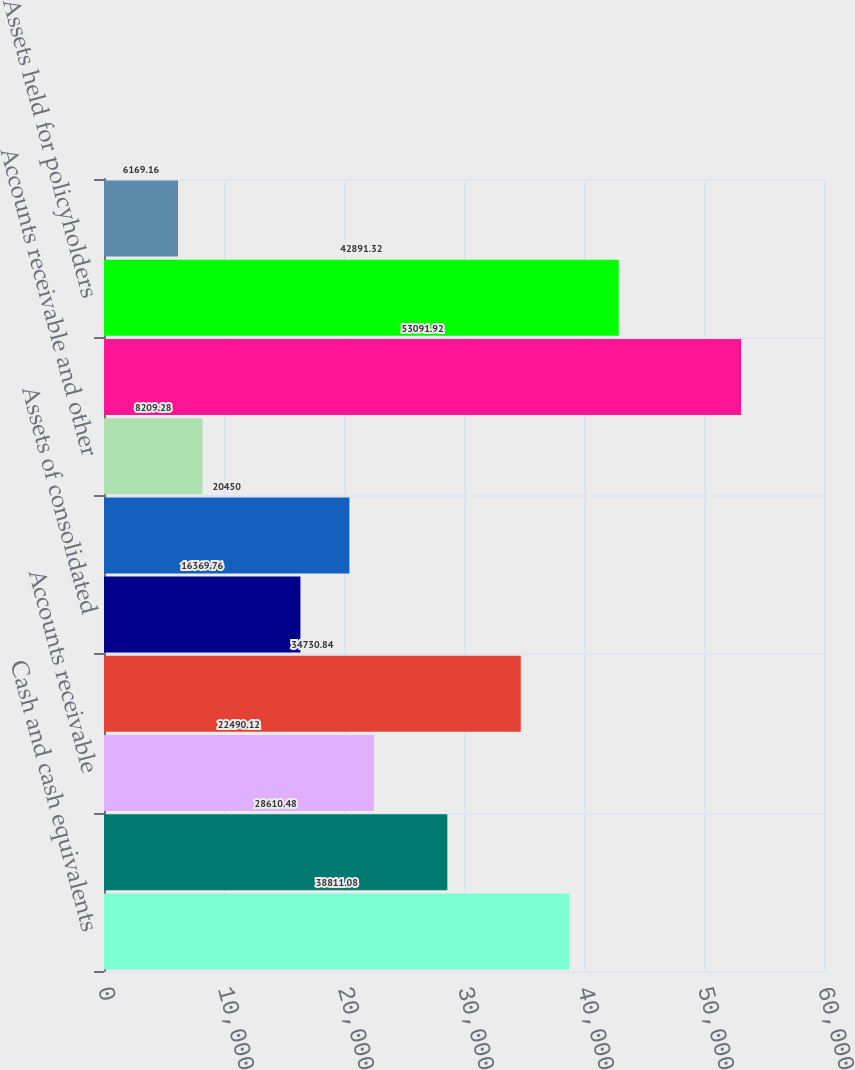Convert chart to OTSL. <chart><loc_0><loc_0><loc_500><loc_500><bar_chart><fcel>Cash and cash equivalents<fcel>Unsettled fund receivables<fcel>Accounts receivable<fcel>Investments<fcel>Assets of consolidated<fcel>Cash and cash equivalents of<fcel>Accounts receivable and other<fcel>Investments of CIP<fcel>Assets held for policyholders<fcel>Prepaid assets<nl><fcel>38811.1<fcel>28610.5<fcel>22490.1<fcel>34730.8<fcel>16369.8<fcel>20450<fcel>8209.28<fcel>53091.9<fcel>42891.3<fcel>6169.16<nl></chart> 